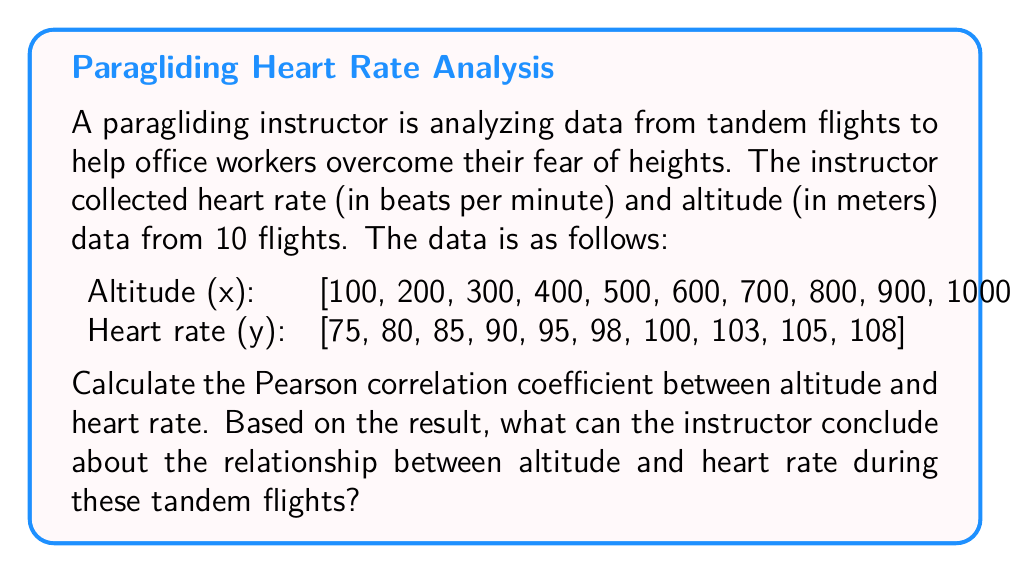Solve this math problem. To calculate the Pearson correlation coefficient, we'll use the formula:

$$ r = \frac{\sum_{i=1}^{n} (x_i - \bar{x})(y_i - \bar{y})}{\sqrt{\sum_{i=1}^{n} (x_i - \bar{x})^2 \sum_{i=1}^{n} (y_i - \bar{y})^2}} $$

Where:
$x_i$ and $y_i$ are the individual sample points
$\bar{x}$ and $\bar{y}$ are the sample means
$n$ is the number of samples

Step 1: Calculate the means
$\bar{x} = \frac{100 + 200 + ... + 1000}{10} = 550$
$\bar{y} = \frac{75 + 80 + ... + 108}{10} = 93.9$

Step 2: Calculate $(x_i - \bar{x})$, $(y_i - \bar{y})$, $(x_i - \bar{x})^2$, $(y_i - \bar{y})^2$, and $(x_i - \bar{x})(y_i - \bar{y})$ for each data point.

Step 3: Sum up the results from step 2:
$\sum (x_i - \bar{x})(y_i - \bar{y}) = 49,275$
$\sum (x_i - \bar{x})^2 = 825,000$
$\sum (y_i - \bar{y})^2 = 1,215.9$

Step 4: Apply the formula:

$$ r = \frac{49,275}{\sqrt{825,000 \times 1,215.9}} = 0.9895 $$

The Pearson correlation coefficient is approximately 0.9895.

This value is very close to 1, indicating a strong positive correlation between altitude and heart rate during the tandem flights. The instructor can conclude that as altitude increases, there is a strong tendency for the heart rate to increase as well. This suggests that the office workers' anxiety levels (as indicated by heart rate) tend to rise with increasing altitude during the paragliding experience.
Answer: The Pearson correlation coefficient is approximately 0.9895, indicating a strong positive correlation between altitude and heart rate during tandem flights. 